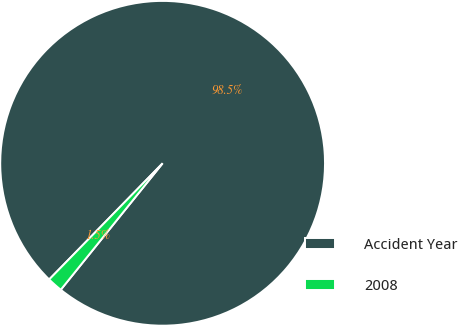Convert chart. <chart><loc_0><loc_0><loc_500><loc_500><pie_chart><fcel>Accident Year<fcel>2008<nl><fcel>98.48%<fcel>1.52%<nl></chart> 